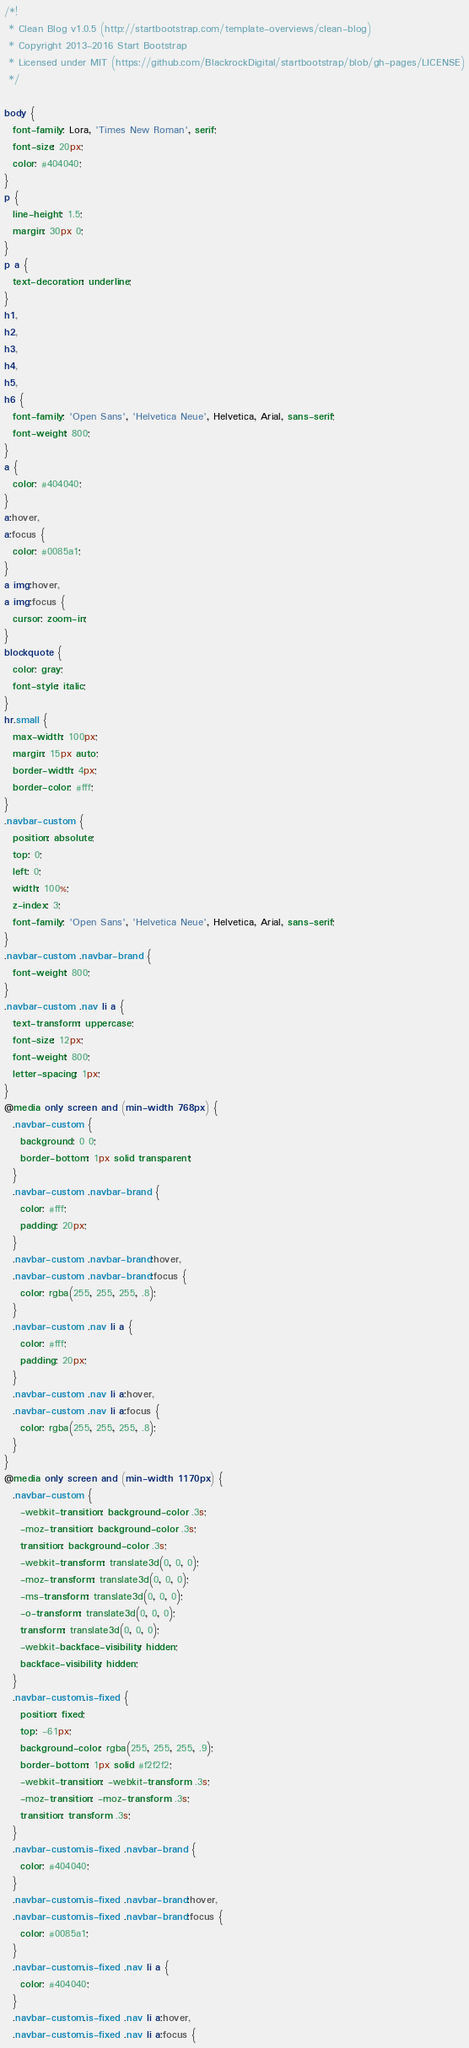<code> <loc_0><loc_0><loc_500><loc_500><_CSS_>/*!
 * Clean Blog v1.0.5 (http://startbootstrap.com/template-overviews/clean-blog)
 * Copyright 2013-2016 Start Bootstrap
 * Licensed under MIT (https://github.com/BlackrockDigital/startbootstrap/blob/gh-pages/LICENSE)
 */

body {
  font-family: Lora, 'Times New Roman', serif;
  font-size: 20px;
  color: #404040;
}
p {
  line-height: 1.5;
  margin: 30px 0;
}
p a {
  text-decoration: underline;
}
h1,
h2,
h3,
h4,
h5,
h6 {
  font-family: 'Open Sans', 'Helvetica Neue', Helvetica, Arial, sans-serif;
  font-weight: 800;
}
a {
  color: #404040;
}
a:hover,
a:focus {
  color: #0085a1;
}
a img:hover,
a img:focus {
  cursor: zoom-in;
}
blockquote {
  color: gray;
  font-style: italic;
}
hr.small {
  max-width: 100px;
  margin: 15px auto;
  border-width: 4px;
  border-color: #fff;
}
.navbar-custom {
  position: absolute;
  top: 0;
  left: 0;
  width: 100%;
  z-index: 3;
  font-family: 'Open Sans', 'Helvetica Neue', Helvetica, Arial, sans-serif;
}
.navbar-custom .navbar-brand {
  font-weight: 800;
}
.navbar-custom .nav li a {
  text-transform: uppercase;
  font-size: 12px;
  font-weight: 800;
  letter-spacing: 1px;
}
@media only screen and (min-width: 768px) {
  .navbar-custom {
    background: 0 0;
    border-bottom: 1px solid transparent;
  }
  .navbar-custom .navbar-brand {
    color: #fff;
    padding: 20px;
  }
  .navbar-custom .navbar-brand:hover,
  .navbar-custom .navbar-brand:focus {
    color: rgba(255, 255, 255, .8);
  }
  .navbar-custom .nav li a {
    color: #fff;
    padding: 20px;
  }
  .navbar-custom .nav li a:hover,
  .navbar-custom .nav li a:focus {
    color: rgba(255, 255, 255, .8);
  }
}
@media only screen and (min-width: 1170px) {
  .navbar-custom {
    -webkit-transition: background-color .3s;
    -moz-transition: background-color .3s;
    transition: background-color .3s;
    -webkit-transform: translate3d(0, 0, 0);
    -moz-transform: translate3d(0, 0, 0);
    -ms-transform: translate3d(0, 0, 0);
    -o-transform: translate3d(0, 0, 0);
    transform: translate3d(0, 0, 0);
    -webkit-backface-visibility: hidden;
    backface-visibility: hidden;
  }
  .navbar-custom.is-fixed {
    position: fixed;
    top: -61px;
    background-color: rgba(255, 255, 255, .9);
    border-bottom: 1px solid #f2f2f2;
    -webkit-transition: -webkit-transform .3s;
    -moz-transition: -moz-transform .3s;
    transition: transform .3s;
  }
  .navbar-custom.is-fixed .navbar-brand {
    color: #404040;
  }
  .navbar-custom.is-fixed .navbar-brand:hover,
  .navbar-custom.is-fixed .navbar-brand:focus {
    color: #0085a1;
  }
  .navbar-custom.is-fixed .nav li a {
    color: #404040;
  }
  .navbar-custom.is-fixed .nav li a:hover,
  .navbar-custom.is-fixed .nav li a:focus {</code> 